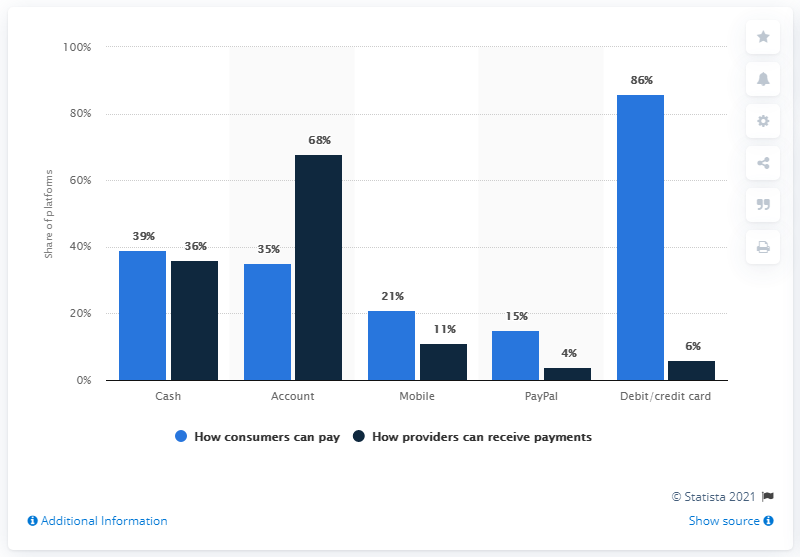Mention a couple of crucial points in this snapshot. The average of the dark blue bar is 25. The value of the lowest light blue bar is 15. 